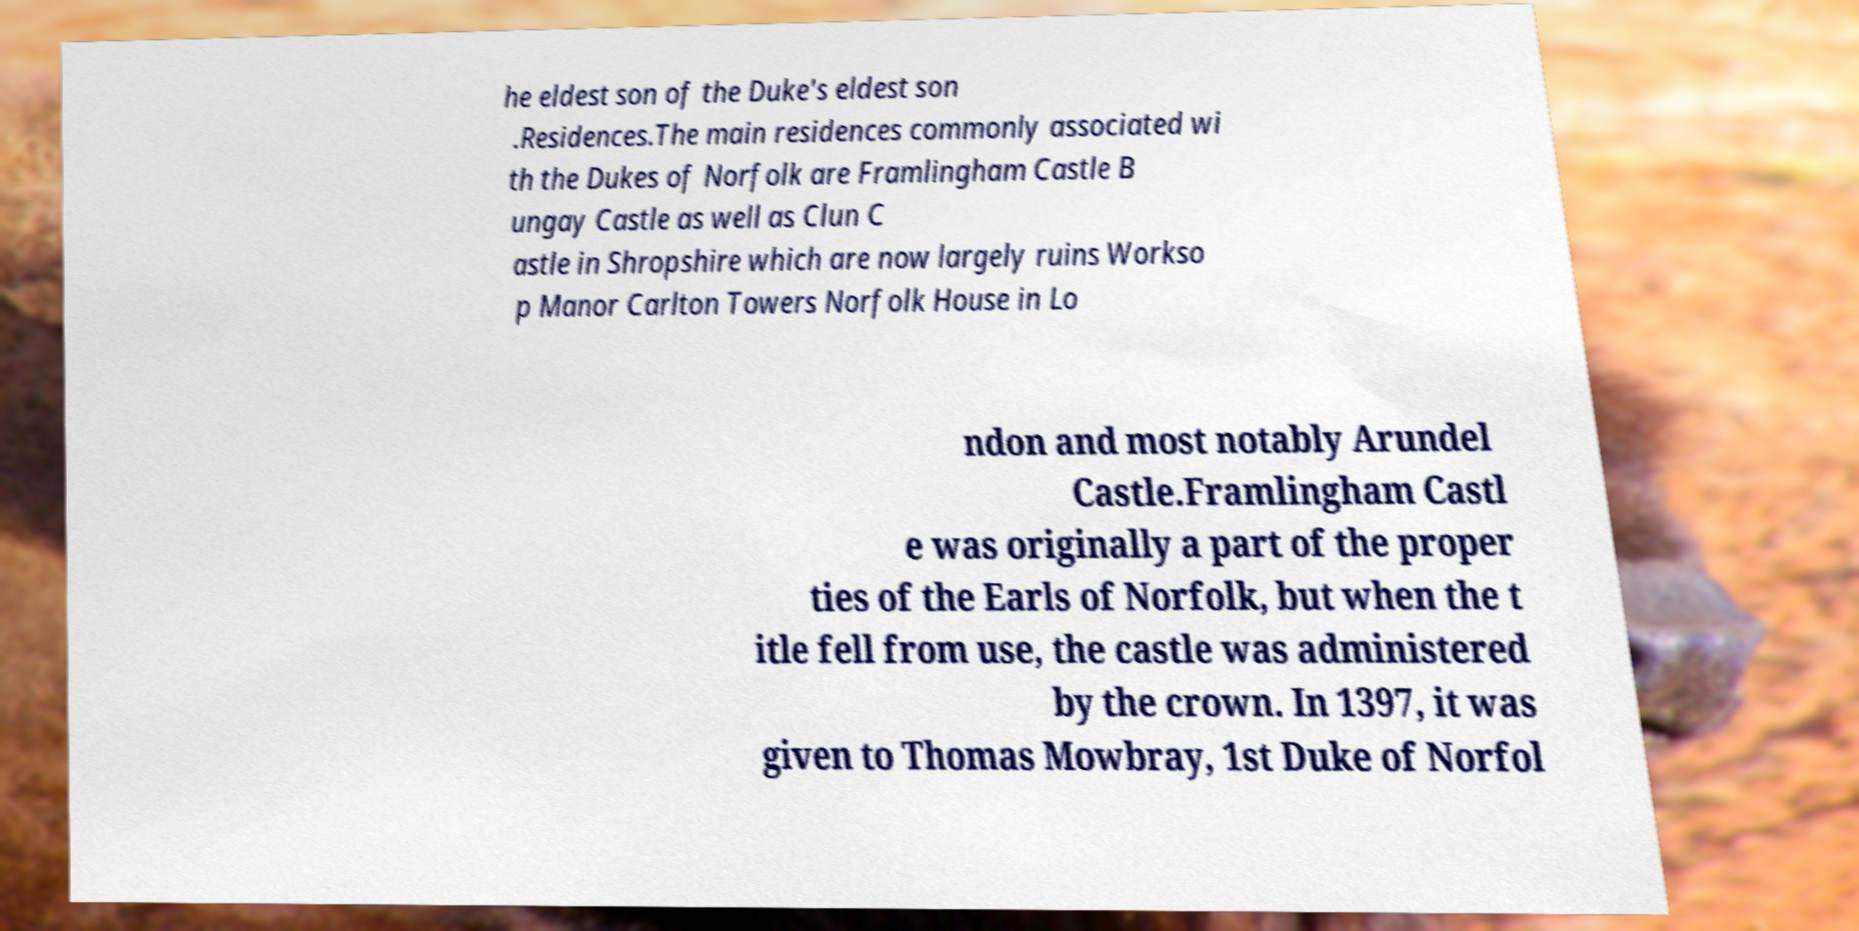There's text embedded in this image that I need extracted. Can you transcribe it verbatim? he eldest son of the Duke's eldest son .Residences.The main residences commonly associated wi th the Dukes of Norfolk are Framlingham Castle B ungay Castle as well as Clun C astle in Shropshire which are now largely ruins Workso p Manor Carlton Towers Norfolk House in Lo ndon and most notably Arundel Castle.Framlingham Castl e was originally a part of the proper ties of the Earls of Norfolk, but when the t itle fell from use, the castle was administered by the crown. In 1397, it was given to Thomas Mowbray, 1st Duke of Norfol 